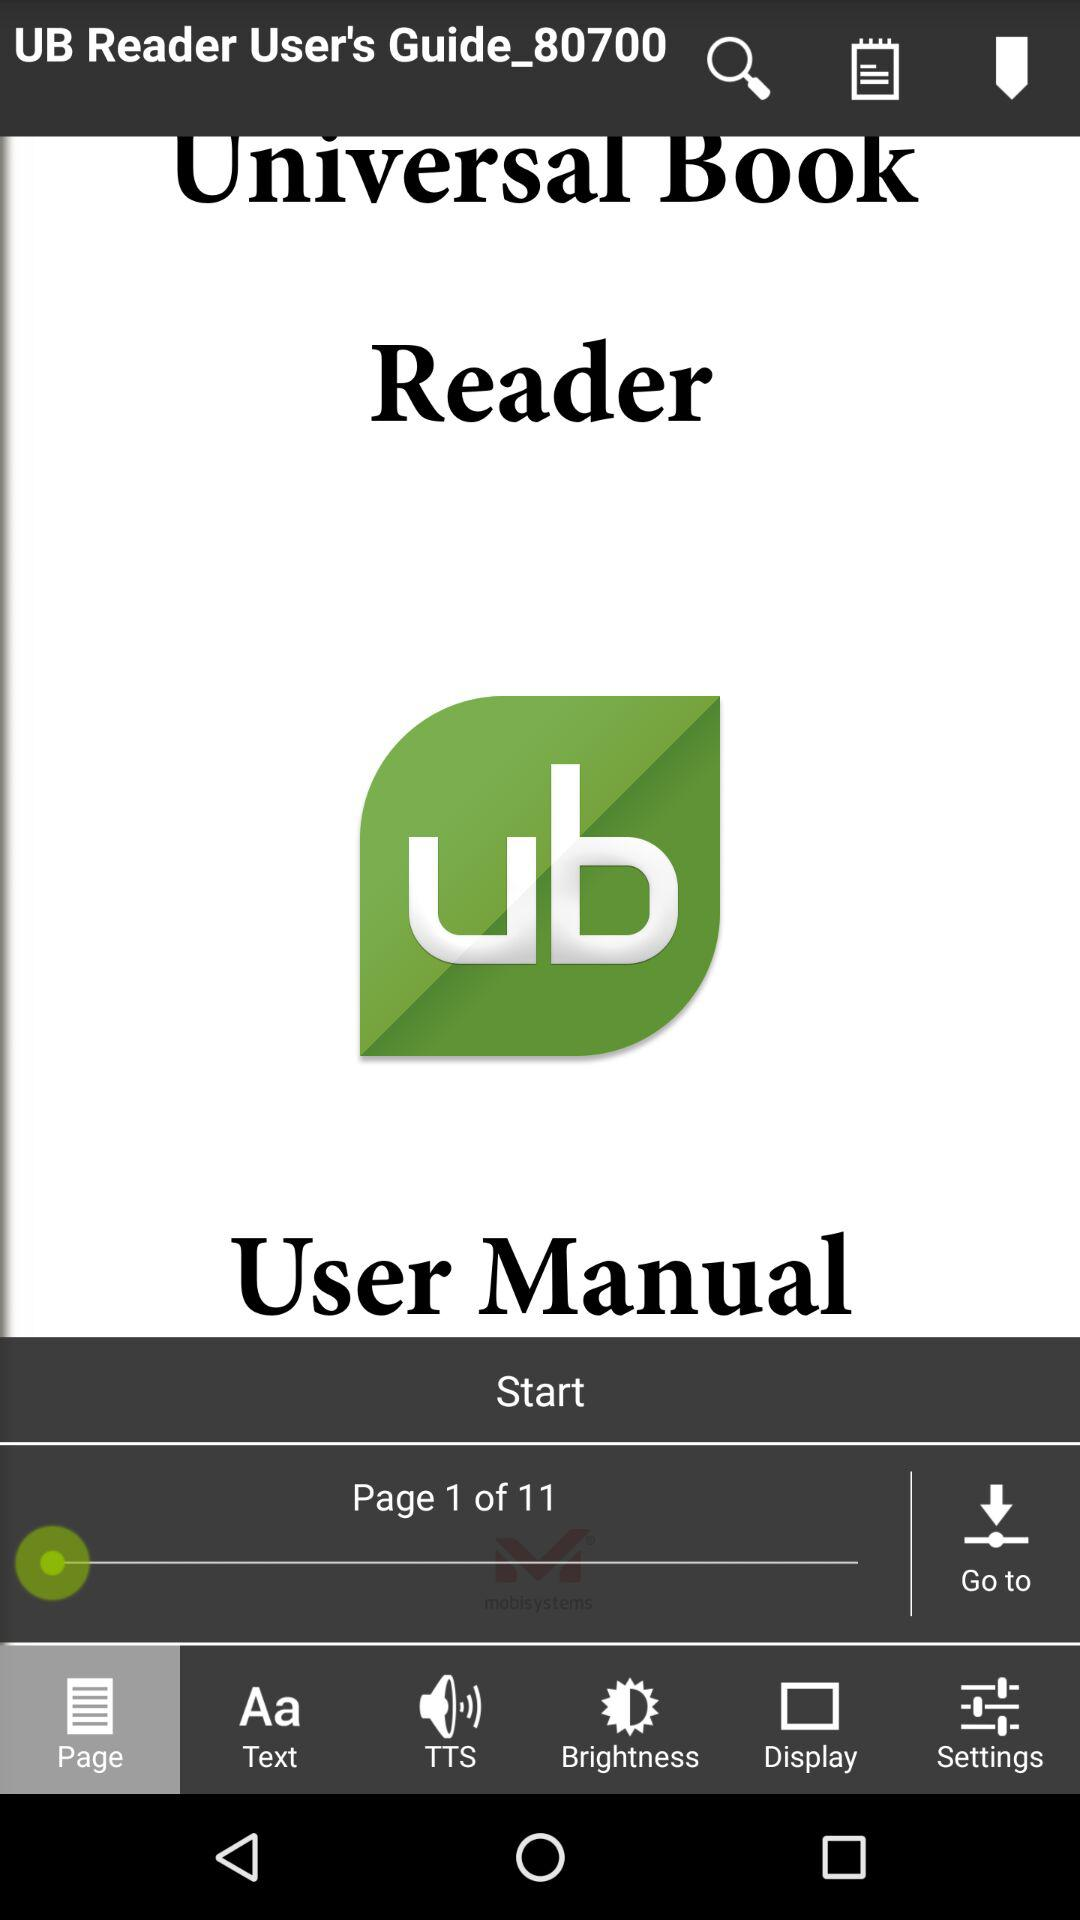What is the total page count of the manual? The total page count of the manual is 11. 